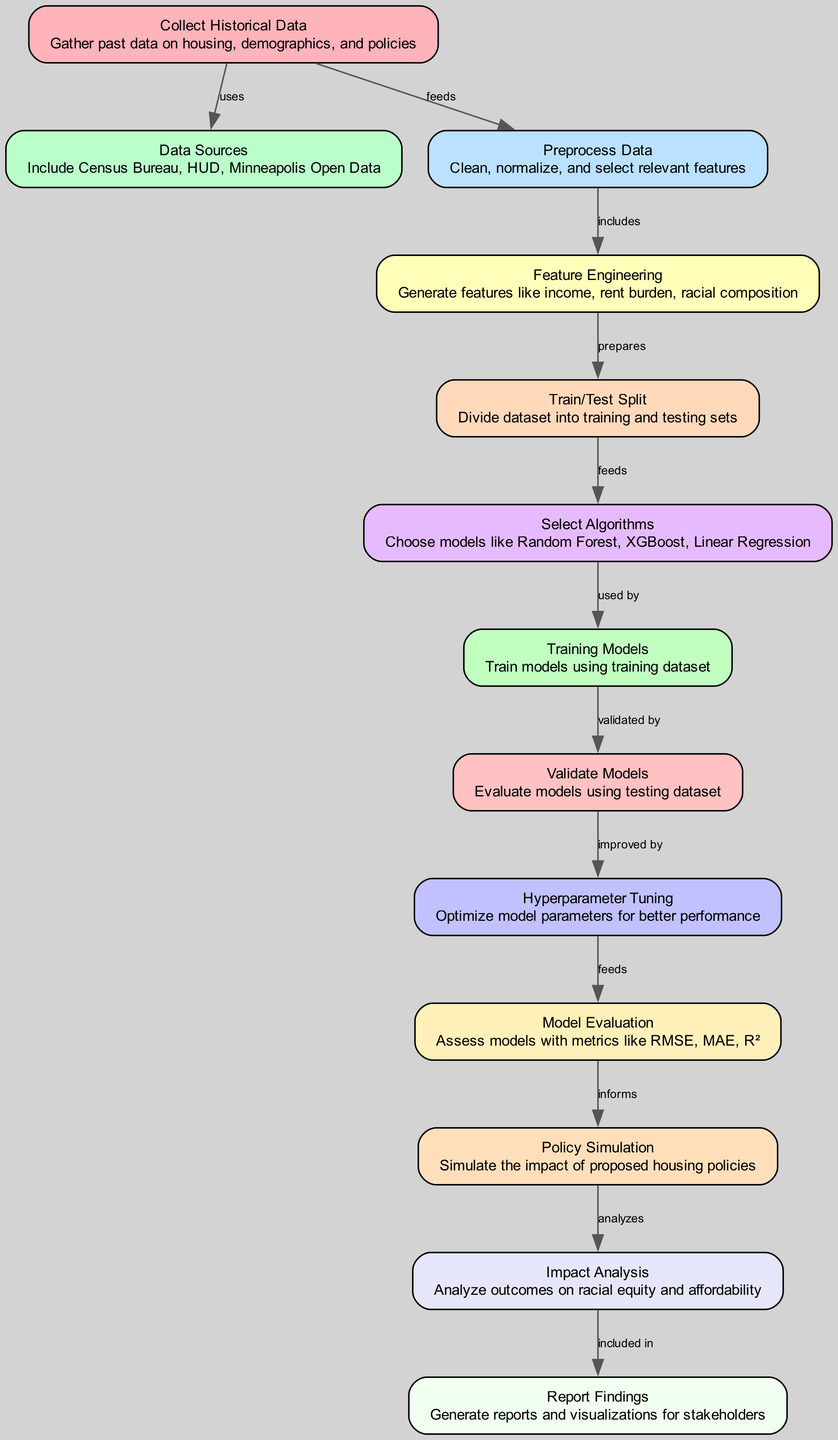What is the first step in the diagram? The diagram begins with the first node labeled "Collect Historical Data," which is the initial step in the process. This step is crucial as it gathers essential historical data needed for further analysis.
Answer: Collect Historical Data How many nodes are in the diagram? By counting the distinct steps outlined in the diagram, we establish that there are a total of thirteen nodes, each representing a unique stage in the process of forecasting the impact of housing policies on racial equity.
Answer: Thirteen Which node does "Feature Engineering" depend on? “Feature Engineering” is depicted as being dependent on the node “Preprocess Data,” which prepares the data with necessary cleaning and normalization before features are created.
Answer: Preprocess Data What is the main purpose of the "Impact Analysis" node? The "Impact Analysis" node focuses on analyzing the outcomes of the simulated policies specifically concerning racial equity and affordability, as depicted in its description.
Answer: Analyze outcomes on racial equity and affordability How does "Training Models" relate to "Validate Models"? The relationship outlined indicates that "Training Models" must occur before "Validate Models," meaning models trained on the dataset need to be validated for performance to establish their effectiveness.
Answer: Validated by What is the end result included in "Report Findings"? The end result of the "Report Findings" node is to generate reports and visualizations that convey the findings of the analysis to stakeholders, creating an essential link for communication.
Answer: Generate reports and visualizations for stakeholders What is used to inform "Policy Simulation"? The "Model Evaluation" node acts as an informing stage for "Policy Simulation," where metrics from the evaluation assess how well the model performs and thus helps guide the simulation of proposed policies.
Answer: Informs Which algorithms are considered in the "Select Algorithms" node? The node "Select Algorithms" suggests the consideration of multiple models including Random Forest, XGBoost, and Linear Regression, which are commonly used in predictive analytics for housing policy analysis.
Answer: Random Forest, XGBoost, Linear Regression What step follows after "Hyperparameter Tuning"? The step that directly follows "Hyperparameter Tuning" is "Model Evaluation," which indicates that after tuning the model parameters, the next action involves assessing the models' performance metrics.
Answer: Model Evaluation 